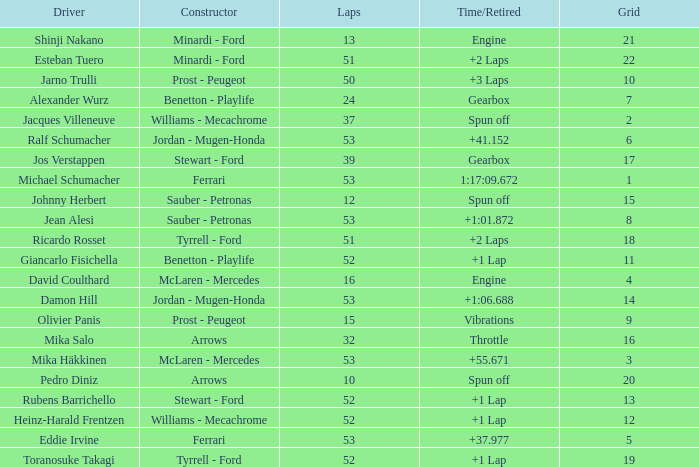Who built the car that went 53 laps with a Time/Retired of 1:17:09.672? Ferrari. 